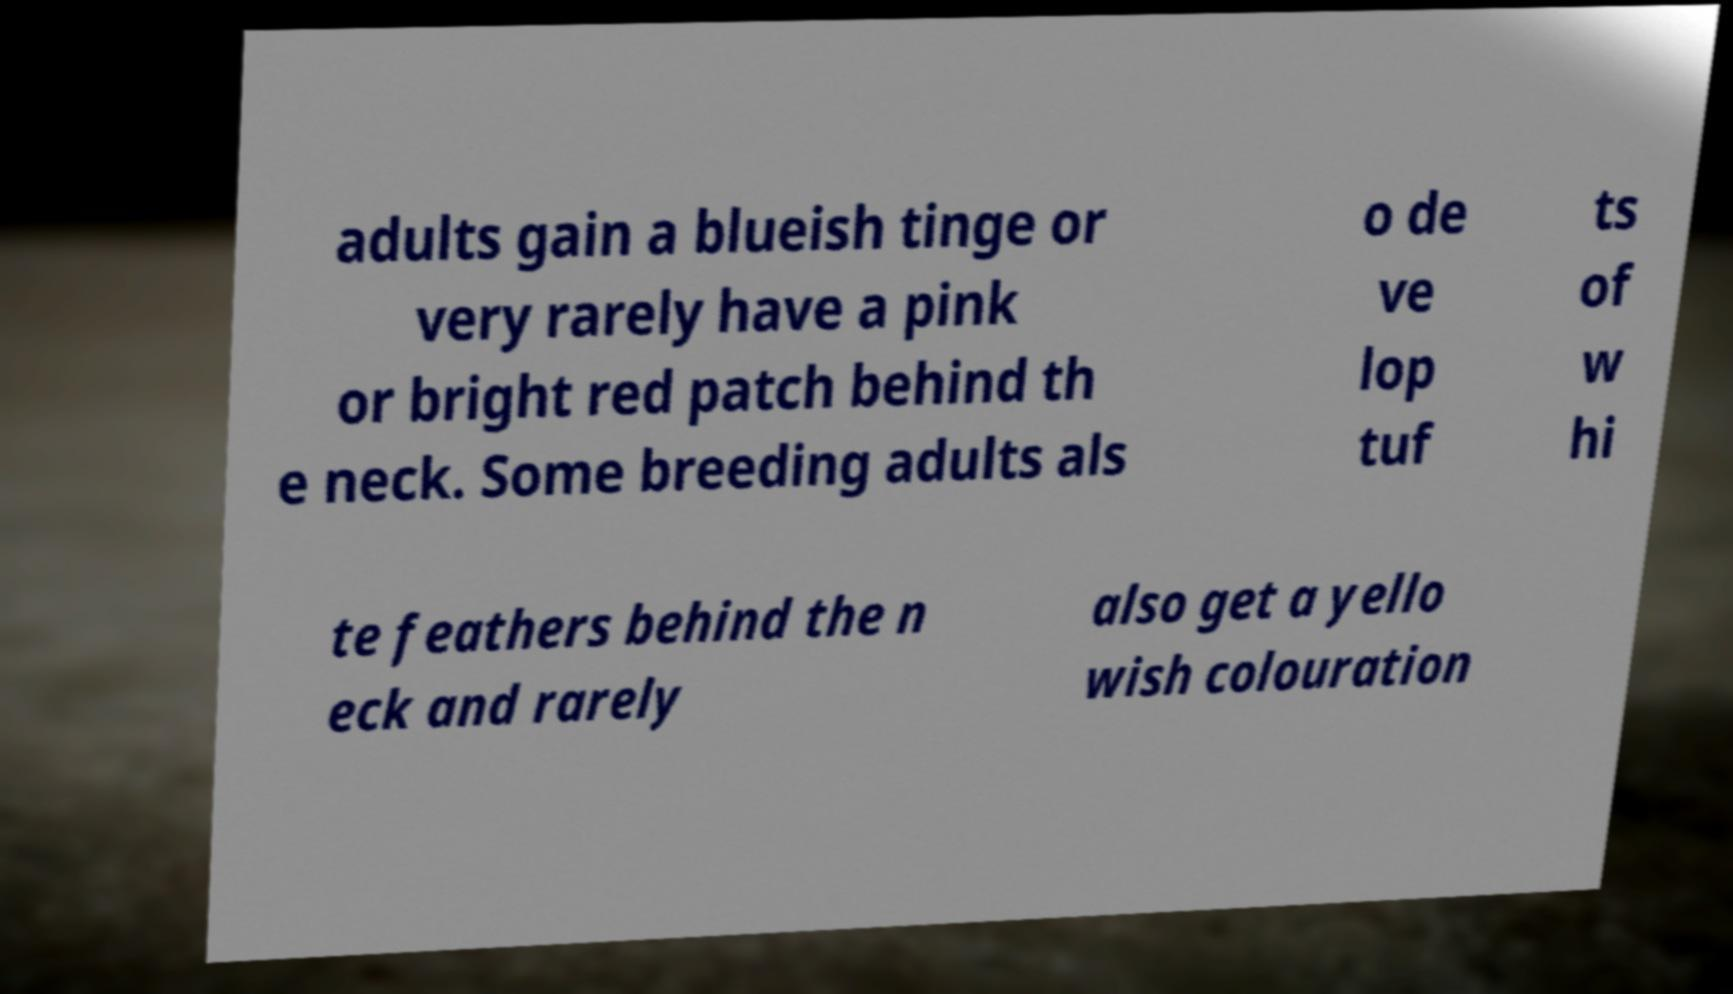For documentation purposes, I need the text within this image transcribed. Could you provide that? adults gain a blueish tinge or very rarely have a pink or bright red patch behind th e neck. Some breeding adults als o de ve lop tuf ts of w hi te feathers behind the n eck and rarely also get a yello wish colouration 